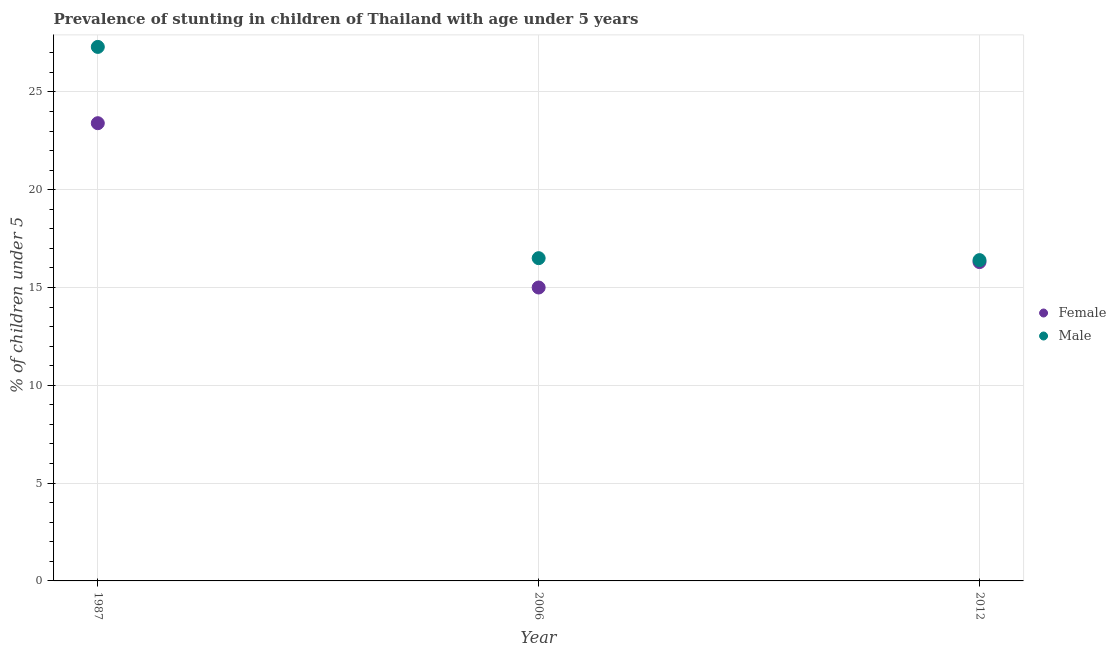How many different coloured dotlines are there?
Make the answer very short. 2. Is the number of dotlines equal to the number of legend labels?
Provide a short and direct response. Yes. What is the percentage of stunted female children in 2006?
Ensure brevity in your answer.  15. Across all years, what is the maximum percentage of stunted female children?
Ensure brevity in your answer.  23.4. In which year was the percentage of stunted female children minimum?
Keep it short and to the point. 2006. What is the total percentage of stunted female children in the graph?
Offer a terse response. 54.7. What is the difference between the percentage of stunted female children in 2006 and that in 2012?
Make the answer very short. -1.3. What is the difference between the percentage of stunted male children in 2006 and the percentage of stunted female children in 2012?
Your response must be concise. 0.2. What is the average percentage of stunted female children per year?
Give a very brief answer. 18.23. In how many years, is the percentage of stunted male children greater than 10 %?
Ensure brevity in your answer.  3. What is the ratio of the percentage of stunted female children in 1987 to that in 2012?
Your answer should be compact. 1.44. Is the difference between the percentage of stunted female children in 1987 and 2012 greater than the difference between the percentage of stunted male children in 1987 and 2012?
Your answer should be very brief. No. What is the difference between the highest and the second highest percentage of stunted male children?
Offer a terse response. 10.8. What is the difference between the highest and the lowest percentage of stunted female children?
Your answer should be very brief. 8.4. Does the percentage of stunted male children monotonically increase over the years?
Ensure brevity in your answer.  No. How many years are there in the graph?
Ensure brevity in your answer.  3. Where does the legend appear in the graph?
Offer a terse response. Center right. How many legend labels are there?
Offer a very short reply. 2. What is the title of the graph?
Your response must be concise. Prevalence of stunting in children of Thailand with age under 5 years. What is the label or title of the Y-axis?
Your answer should be very brief.  % of children under 5. What is the  % of children under 5 of Female in 1987?
Give a very brief answer. 23.4. What is the  % of children under 5 of Male in 1987?
Offer a very short reply. 27.3. What is the  % of children under 5 in Female in 2012?
Provide a short and direct response. 16.3. What is the  % of children under 5 of Male in 2012?
Make the answer very short. 16.4. Across all years, what is the maximum  % of children under 5 of Female?
Provide a short and direct response. 23.4. Across all years, what is the maximum  % of children under 5 of Male?
Provide a succinct answer. 27.3. Across all years, what is the minimum  % of children under 5 in Male?
Keep it short and to the point. 16.4. What is the total  % of children under 5 of Female in the graph?
Offer a terse response. 54.7. What is the total  % of children under 5 in Male in the graph?
Your answer should be compact. 60.2. What is the difference between the  % of children under 5 in Female in 1987 and that in 2006?
Your answer should be compact. 8.4. What is the difference between the  % of children under 5 of Female in 1987 and that in 2012?
Provide a succinct answer. 7.1. What is the difference between the  % of children under 5 in Male in 1987 and that in 2012?
Your response must be concise. 10.9. What is the difference between the  % of children under 5 of Female in 2006 and that in 2012?
Your answer should be compact. -1.3. What is the average  % of children under 5 in Female per year?
Give a very brief answer. 18.23. What is the average  % of children under 5 of Male per year?
Offer a terse response. 20.07. In the year 1987, what is the difference between the  % of children under 5 in Female and  % of children under 5 in Male?
Your answer should be compact. -3.9. In the year 2006, what is the difference between the  % of children under 5 of Female and  % of children under 5 of Male?
Ensure brevity in your answer.  -1.5. What is the ratio of the  % of children under 5 of Female in 1987 to that in 2006?
Your answer should be very brief. 1.56. What is the ratio of the  % of children under 5 of Male in 1987 to that in 2006?
Offer a terse response. 1.65. What is the ratio of the  % of children under 5 of Female in 1987 to that in 2012?
Ensure brevity in your answer.  1.44. What is the ratio of the  % of children under 5 in Male in 1987 to that in 2012?
Ensure brevity in your answer.  1.66. What is the ratio of the  % of children under 5 of Female in 2006 to that in 2012?
Keep it short and to the point. 0.92. What is the ratio of the  % of children under 5 of Male in 2006 to that in 2012?
Make the answer very short. 1.01. What is the difference between the highest and the second highest  % of children under 5 of Female?
Make the answer very short. 7.1. What is the difference between the highest and the lowest  % of children under 5 in Female?
Give a very brief answer. 8.4. What is the difference between the highest and the lowest  % of children under 5 of Male?
Provide a short and direct response. 10.9. 